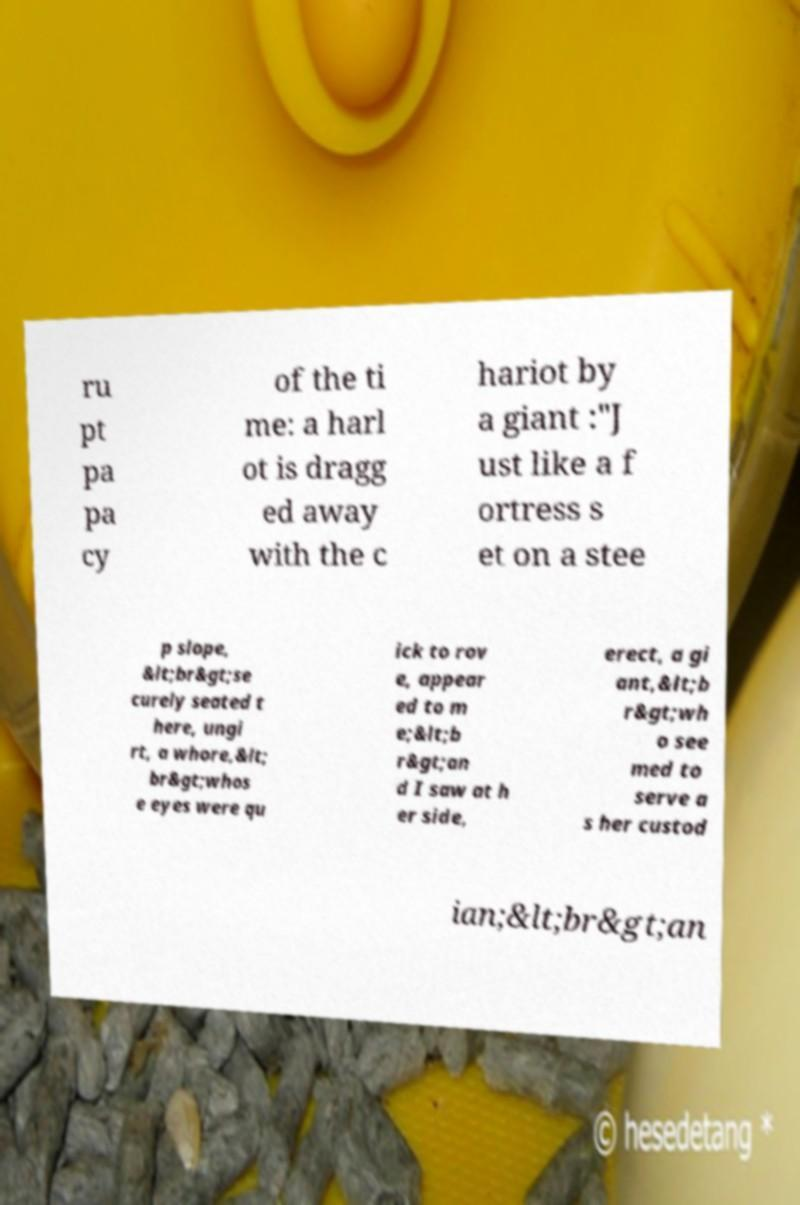Please identify and transcribe the text found in this image. ru pt pa pa cy of the ti me: a harl ot is dragg ed away with the c hariot by a giant :"J ust like a f ortress s et on a stee p slope, &lt;br&gt;se curely seated t here, ungi rt, a whore,&lt; br&gt;whos e eyes were qu ick to rov e, appear ed to m e;&lt;b r&gt;an d I saw at h er side, erect, a gi ant,&lt;b r&gt;wh o see med to serve a s her custod ian;&lt;br&gt;an 